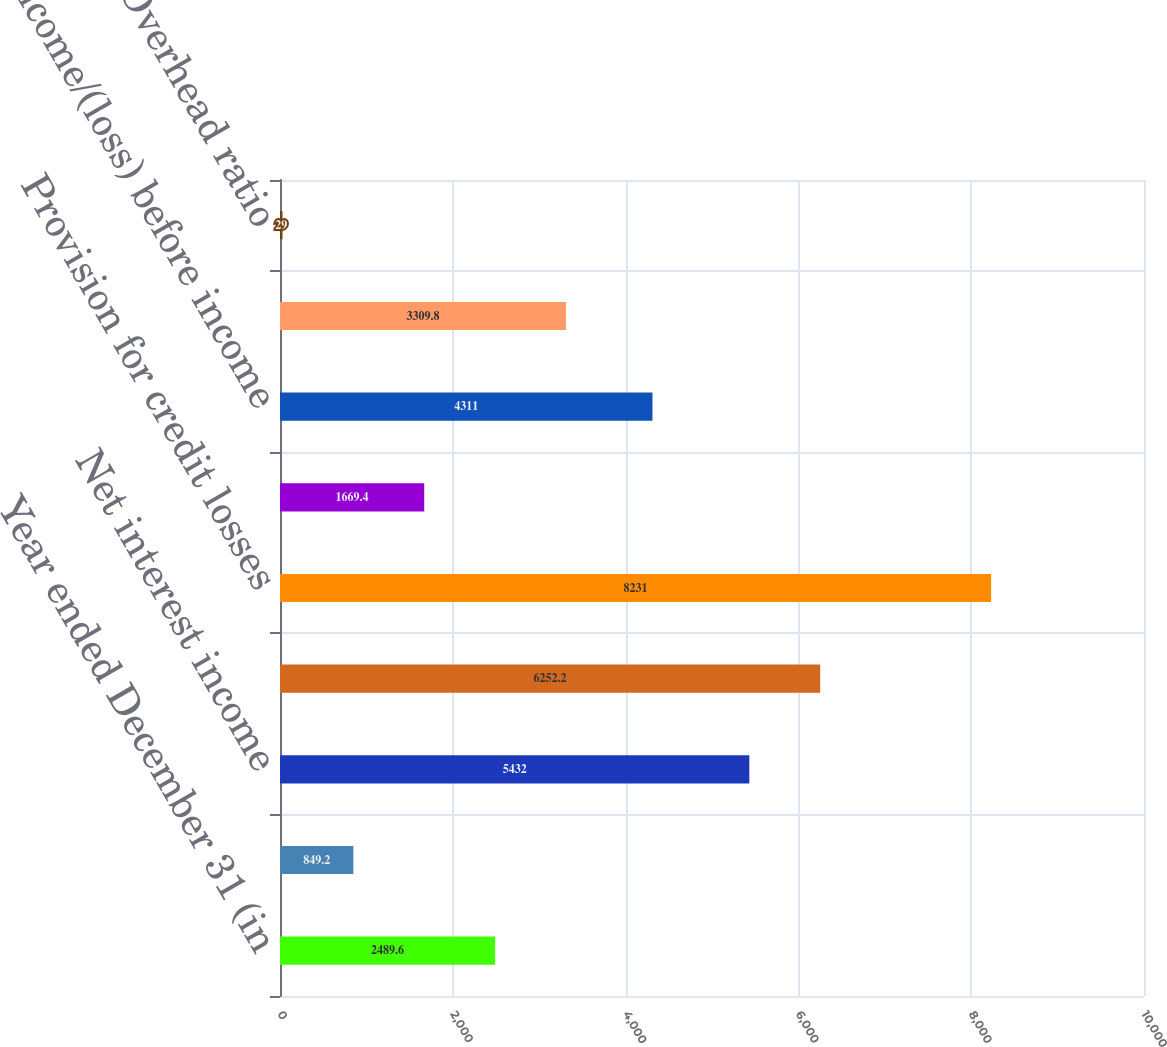Convert chart. <chart><loc_0><loc_0><loc_500><loc_500><bar_chart><fcel>Year ended December 31 (in<fcel>Noninterest revenue<fcel>Net interest income<fcel>Total net revenue<fcel>Provision for credit losses<fcel>Noninterest expense<fcel>Income/(loss) before income<fcel>Net income/(loss)<fcel>Overhead ratio<nl><fcel>2489.6<fcel>849.2<fcel>5432<fcel>6252.2<fcel>8231<fcel>1669.4<fcel>4311<fcel>3309.8<fcel>29<nl></chart> 